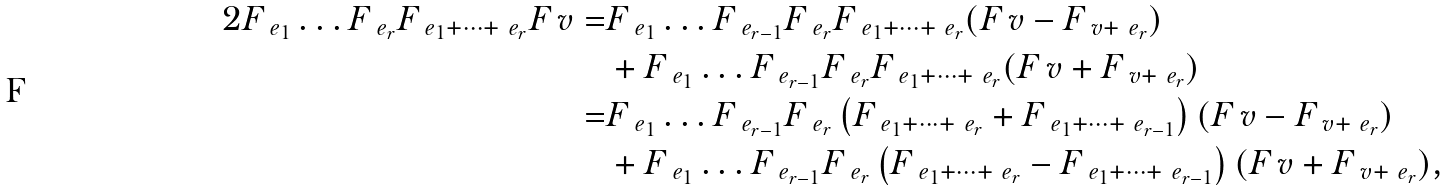Convert formula to latex. <formula><loc_0><loc_0><loc_500><loc_500>2 F _ { \ e _ { 1 } } \dots F _ { \ e _ { r } } F _ { \ e _ { 1 } + \dots + \ e _ { r } } F _ { \ } v = & F _ { \ e _ { 1 } } \dots F _ { \ e _ { r - 1 } } F _ { \ e _ { r } } F _ { \ e _ { 1 } + \dots + \ e _ { r } } ( F _ { \ } v - F _ { \ v + \ e _ { r } } ) \\ & + F _ { \ e _ { 1 } } \dots F _ { \ e _ { r - 1 } } F _ { \ e _ { r } } F _ { \ e _ { 1 } + \dots + \ e _ { r } } ( F _ { \ } v + F _ { \ v + \ e _ { r } } ) \\ = & F _ { \ e _ { 1 } } \dots F _ { \ e _ { r - 1 } } F _ { \ e _ { r } } \left ( F _ { \ e _ { 1 } + \dots + \ e _ { r } } + F _ { \ e _ { 1 } + \dots + \ e _ { r - 1 } } \right ) ( F _ { \ } v - F _ { \ v + \ e _ { r } } ) \\ & + F _ { \ e _ { 1 } } \dots F _ { \ e _ { r - 1 } } F _ { \ e _ { r } } \left ( F _ { \ e _ { 1 } + \dots + \ e _ { r } } - F _ { \ e _ { 1 } + \dots + \ e _ { r - 1 } } \right ) ( F _ { \ } v + F _ { \ v + \ e _ { r } } ) ,</formula> 